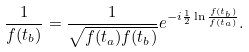<formula> <loc_0><loc_0><loc_500><loc_500>\frac { 1 } { f ( t _ { b } ) } = \frac { 1 } { \sqrt { f ( t _ { a } ) f ( t _ { b } ) } } e ^ { - i \frac { 1 } { 2 } \ln \frac { f ( t _ { b } ) } { f ( t _ { a } ) } } .</formula> 